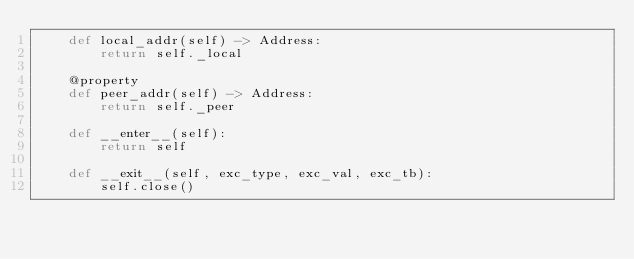Convert code to text. <code><loc_0><loc_0><loc_500><loc_500><_Python_>    def local_addr(self) -> Address:
        return self._local

    @property
    def peer_addr(self) -> Address:
        return self._peer

    def __enter__(self):
        return self

    def __exit__(self, exc_type, exc_val, exc_tb):
        self.close()
</code> 